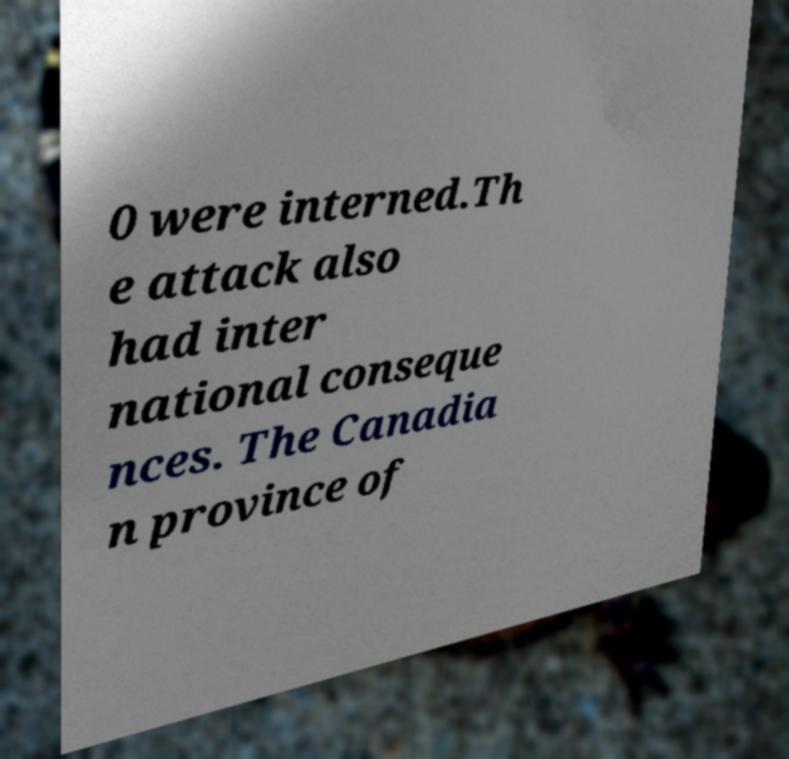I need the written content from this picture converted into text. Can you do that? 0 were interned.Th e attack also had inter national conseque nces. The Canadia n province of 